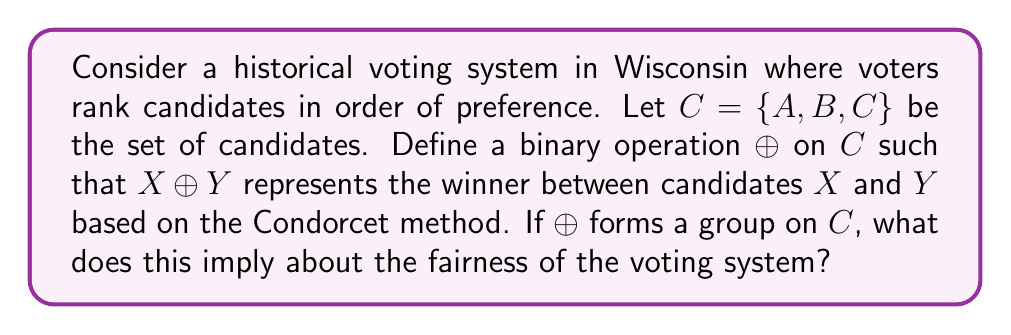Solve this math problem. Let's approach this step-by-step:

1) First, recall that for $\oplus$ to form a group on $C$, it must satisfy four properties: closure, associativity, identity, and inverses.

2) Closure: For any $X, Y \in C$, $X \oplus Y \in C$. This is satisfied as the winner between any two candidates is always a candidate.

3) Associativity: $(X \oplus Y) \oplus Z = X \oplus (Y \oplus Z)$ for all $X, Y, Z \in C$. This property is not necessarily satisfied in a Condorcet method, as the order of pairwise comparisons can matter.

4) Identity: There should exist an $e \in C$ such that $X \oplus e = e \oplus X = X$ for all $X \in C$. In a fair voting system, no candidate should automatically lose to all others, so this property is not satisfied.

5) Inverses: For each $X \in C$, there should exist a $Y \in C$ such that $X \oplus Y = Y \oplus X = e$. Again, in a fair system, no candidate should automatically beat another in all cases.

6) Since not all group properties are satisfied, $\oplus$ does not form a group on $C$.

7) This implies that the voting system has some inherent asymmetries or biases. If it did form a group, it would suggest a perfectly balanced system where each candidate has an equal chance against the others, which is unrealistic in practice.

8) The lack of group structure actually reflects a more realistic and potentially fairer system, where voters' preferences can create meaningful distinctions between candidates.
Answer: The lack of group structure implies a more realistic and potentially fairer voting system. 